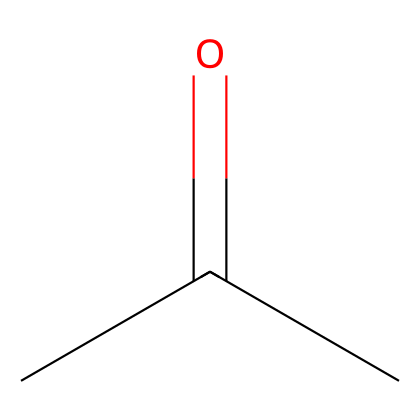What is the molecular formula of this compound? The SMILES representation CC(=O)C indicates that the molecule has three carbon atoms (C), six hydrogen atoms (H), and one oxygen atom (O). Therefore, the molecular formula is derived by counting these atoms.
Answer: C3H6O How many carbon atoms are present in this molecule? In the SMILES representation CC(=O)C, there are three separate carbon (C) symbols which indicate the presence of three carbon atoms.
Answer: 3 What type of functional group is present in this compound? The SMILES shows the carbonyl group (=O) connected to a carbon atom, indicating that this compound has a ketone functional group. This is identified by the C=O structure, characteristic of ketones.
Answer: ketone Is this compound considered flammable? Acetone is a known flammable liquid, which is an essential property for flammable liquids, demonstrating high volatility and combustion potential. As such, based on its classification, it is indeed flammable.
Answer: yes What is the significance of the carbonyl group in this chemical? The presence of the carbonyl group (C=O) in acetone is critical for its reactivity and solubility in polar solvents, contributing to its effectiveness as a solvent for cleaning laboratory glassware. This group also influences its boiling point and chemical behavior.
Answer: reactivity How many hydrogen atoms are there in relation to the number of carbon atoms? For this molecule, there are six hydrogen atoms for every three carbon atoms present as indicated in the molecular formula C3H6O. This shows a ratio of hydrogen to carbon of 2:1, which is typical for aliphatic compounds.
Answer: 2:1 